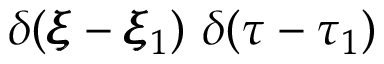Convert formula to latex. <formula><loc_0><loc_0><loc_500><loc_500>\delta ( \pm b { \xi } - \pm b { \xi } _ { 1 } ) \delta ( \tau - \tau _ { 1 } )</formula> 